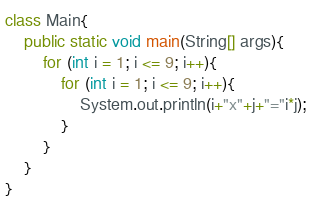<code> <loc_0><loc_0><loc_500><loc_500><_Java_>class Main{
    public static void main(String[] args){
        for (int i = 1; i <= 9; i++){
            for (int i = 1; i <= 9; i++){
                System.out.println(i+"x"+j+"="i*j);
            }
        }
    }
}</code> 